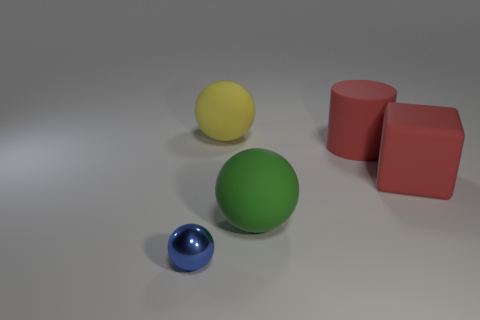What number of tiny objects are either matte cylinders or red cubes? In the image, there is a total of one red cube. There are no matte cylinders visible, so the answer to your question would be one, if we're only considering the red cubes. However, if we also count the blue sphere as tiny, the count would be two objects of note. 